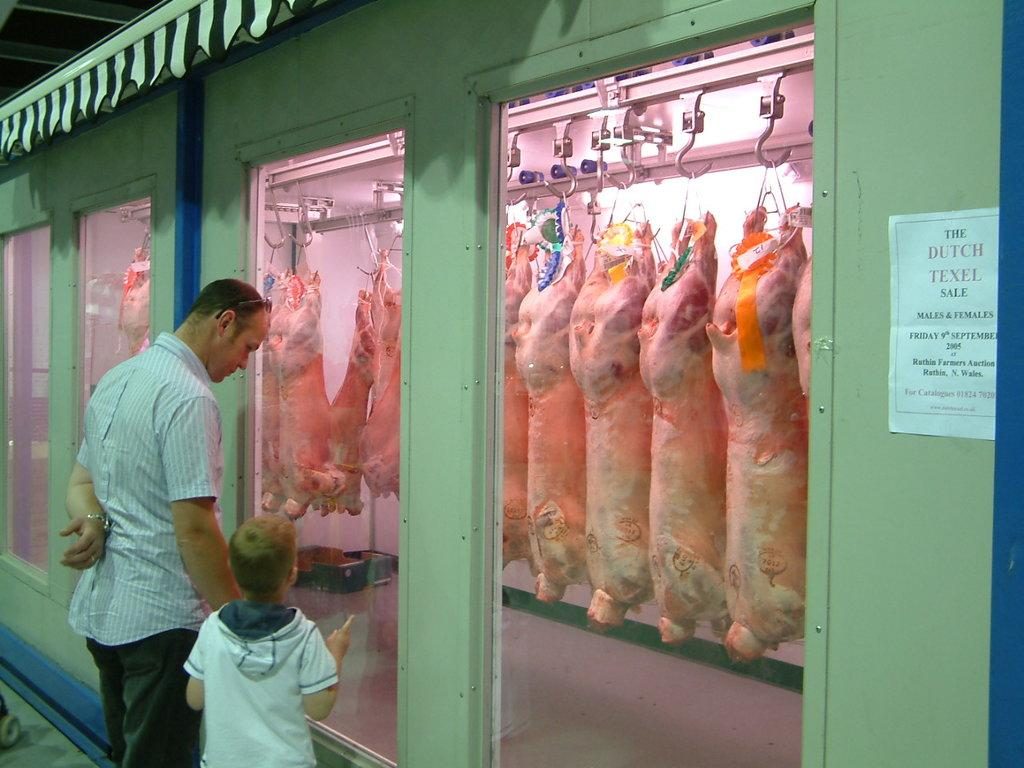How many people are present in the image? There are two people standing in front of the shed. What can be seen inside the shed? There is meat hanging from hooks inside the shed. Is there any additional information attached to the shed? Yes, there is a paper attached to the shed. What type of fruit is being held by the person on the left in the image? There is no fruit visible in the image, and neither person is holding anything. 